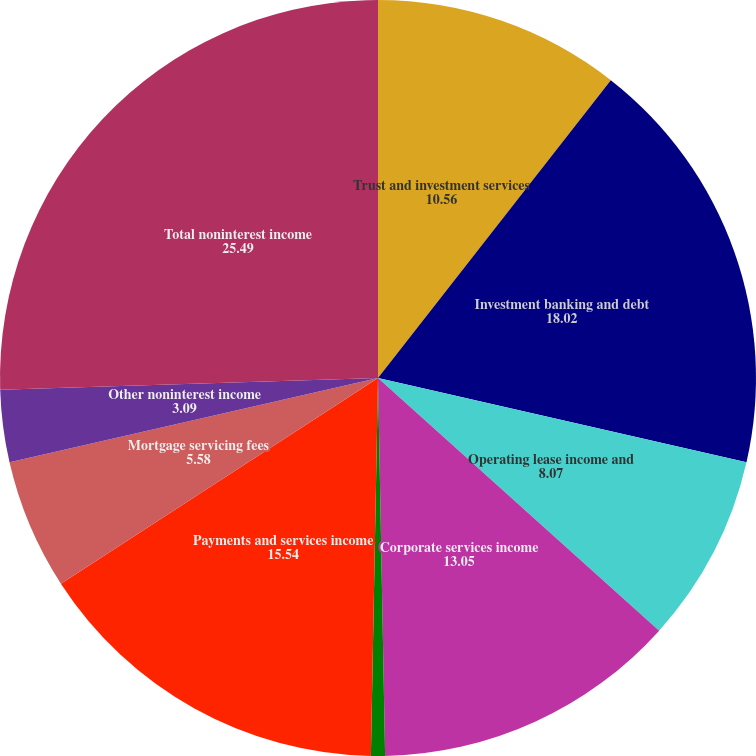Convert chart. <chart><loc_0><loc_0><loc_500><loc_500><pie_chart><fcel>Trust and investment services<fcel>Investment banking and debt<fcel>Operating lease income and<fcel>Corporate services income<fcel>Cards and payments income<fcel>Payments and services income<fcel>Mortgage servicing fees<fcel>Other noninterest income<fcel>Total noninterest income<nl><fcel>10.56%<fcel>18.02%<fcel>8.07%<fcel>13.05%<fcel>0.6%<fcel>15.54%<fcel>5.58%<fcel>3.09%<fcel>25.49%<nl></chart> 